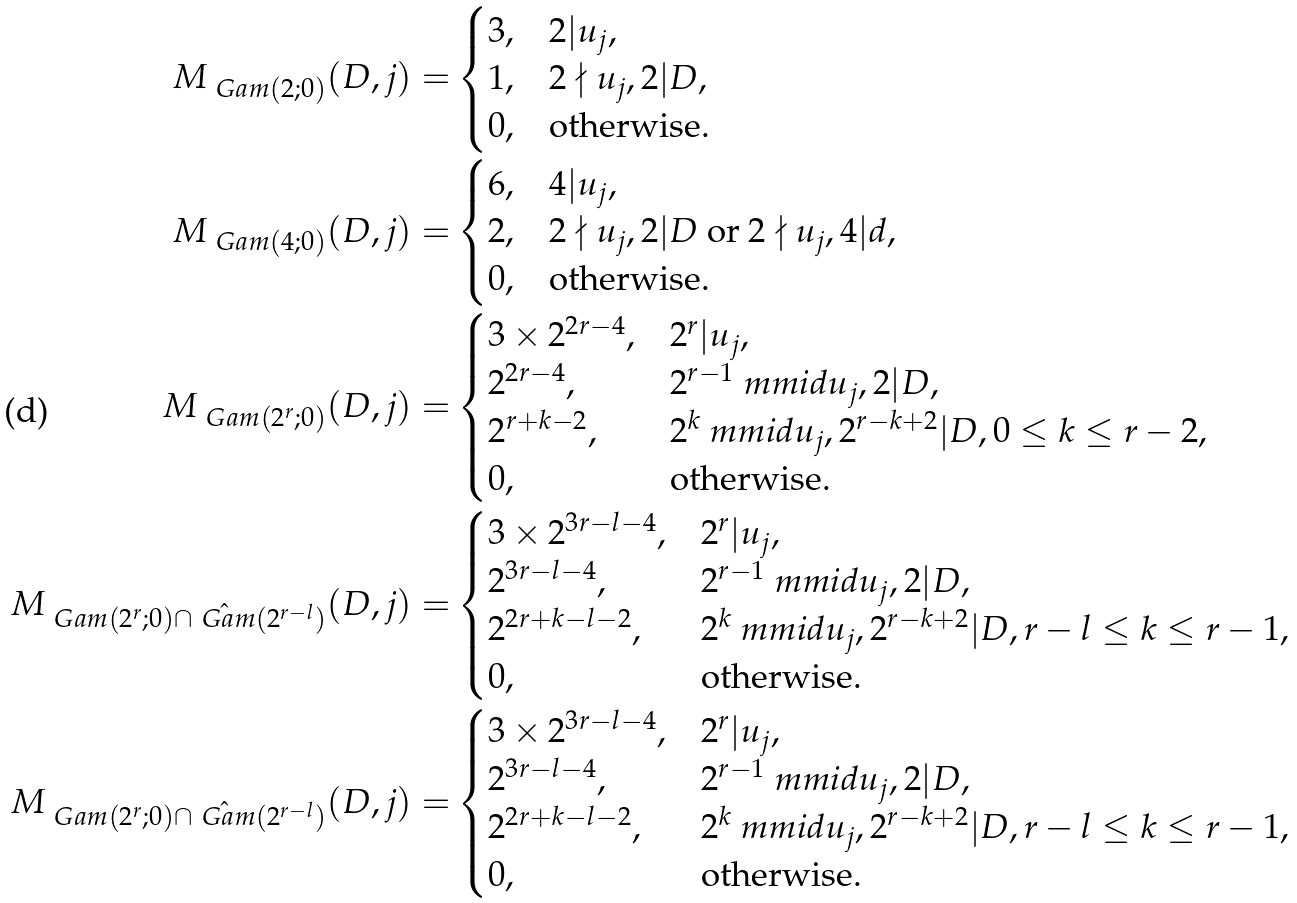<formula> <loc_0><loc_0><loc_500><loc_500>M _ { \ G a m ( 2 ; 0 ) } ( D , j ) = & \begin{cases} 3 , & 2 | u _ { j } , \\ 1 , & 2 \nmid u _ { j } , 2 | D , \\ 0 , & \text {otherwise} . \end{cases} \\ M _ { \ G a m ( 4 ; 0 ) } ( D , j ) = & \begin{cases} 6 , & 4 | u _ { j } , \\ 2 , & \text {$2\nmid u_{j},2| D$ or $2\nmid u_{j},4| d$} , \\ 0 , & \text {otherwise} . \end{cases} \\ M _ { \ G a m ( 2 ^ { r } ; 0 ) } ( D , j ) = & \begin{cases} 3 \times 2 ^ { 2 r - 4 } , & 2 ^ { r } | u _ { j } , \\ 2 ^ { 2 r - 4 } , & 2 ^ { r - 1 } \ m m i d u _ { j } , 2 | D , \\ 2 ^ { r + k - 2 } , & 2 ^ { k } \ m m i d u _ { j } , 2 ^ { r - k + 2 } | D , 0 \leq k \leq r - 2 , \\ 0 , & \text {otherwise} . \end{cases} \\ M _ { \ G a m ( 2 ^ { r } ; 0 ) \cap \hat { \ G a m } ( 2 ^ { r - l } ) } ( D , j ) = & \begin{cases} 3 \times 2 ^ { 3 r - l - 4 } , & 2 ^ { r } | u _ { j } , \\ 2 ^ { 3 r - l - 4 } , & 2 ^ { r - 1 } \ m m i d u _ { j } , 2 | D , \\ 2 ^ { 2 r + k - l - 2 } , & 2 ^ { k } \ m m i d u _ { j } , 2 ^ { r - k + 2 } | D , r - l \leq k \leq r - 1 , \\ 0 , & \text {otherwise} . \end{cases} \\ M _ { \ G a m ( 2 ^ { r } ; 0 ) \cap \hat { \ G a m } ( 2 ^ { r - l } ) } ( D , j ) = & \begin{cases} 3 \times 2 ^ { 3 r - l - 4 } , & 2 ^ { r } | u _ { j } , \\ 2 ^ { 3 r - l - 4 } , & 2 ^ { r - 1 } \ m m i d u _ { j } , 2 | D , \\ 2 ^ { 2 r + k - l - 2 } , & 2 ^ { k } \ m m i d u _ { j } , 2 ^ { r - k + 2 } | D , r - l \leq k \leq r - 1 , \\ 0 , & \text {otherwise} . \end{cases} \\</formula> 